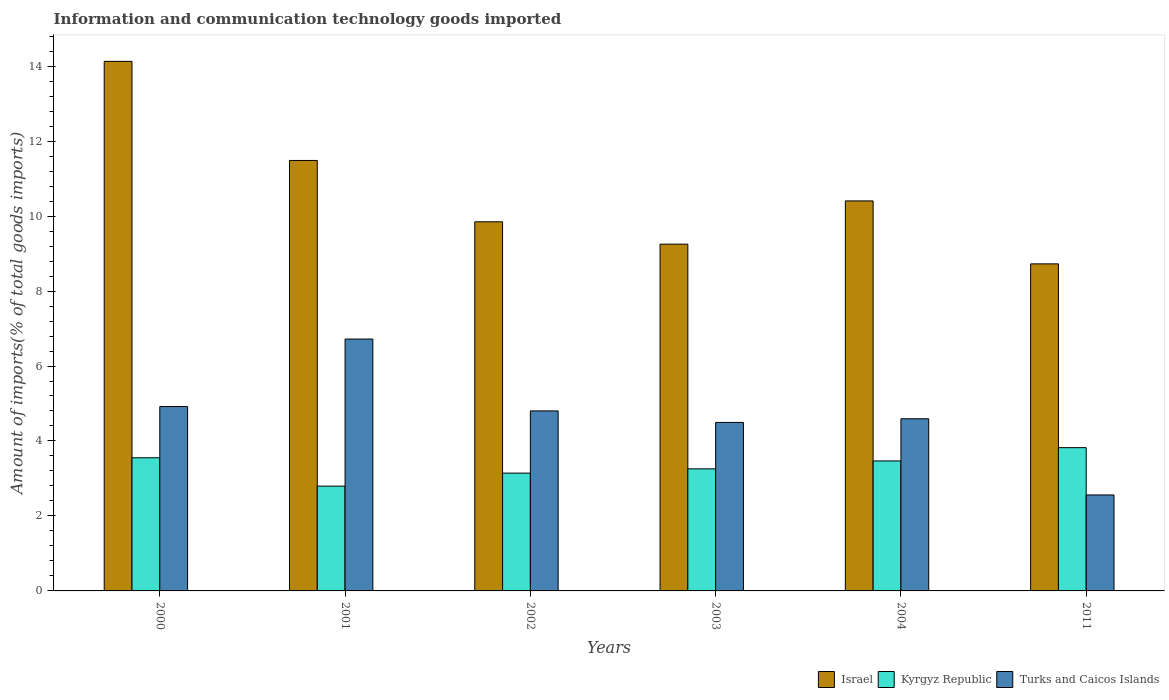Are the number of bars per tick equal to the number of legend labels?
Offer a terse response. Yes. How many bars are there on the 3rd tick from the left?
Your response must be concise. 3. How many bars are there on the 5th tick from the right?
Your answer should be very brief. 3. What is the label of the 5th group of bars from the left?
Your answer should be compact. 2004. What is the amount of goods imported in Turks and Caicos Islands in 2002?
Your response must be concise. 4.8. Across all years, what is the maximum amount of goods imported in Turks and Caicos Islands?
Make the answer very short. 6.72. Across all years, what is the minimum amount of goods imported in Turks and Caicos Islands?
Make the answer very short. 2.56. What is the total amount of goods imported in Turks and Caicos Islands in the graph?
Your answer should be compact. 28.09. What is the difference between the amount of goods imported in Kyrgyz Republic in 2002 and that in 2003?
Offer a very short reply. -0.11. What is the difference between the amount of goods imported in Israel in 2002 and the amount of goods imported in Kyrgyz Republic in 2004?
Keep it short and to the point. 6.38. What is the average amount of goods imported in Kyrgyz Republic per year?
Keep it short and to the point. 3.34. In the year 2000, what is the difference between the amount of goods imported in Turks and Caicos Islands and amount of goods imported in Kyrgyz Republic?
Provide a short and direct response. 1.37. In how many years, is the amount of goods imported in Kyrgyz Republic greater than 14 %?
Offer a terse response. 0. What is the ratio of the amount of goods imported in Turks and Caicos Islands in 2001 to that in 2004?
Your answer should be compact. 1.46. Is the difference between the amount of goods imported in Turks and Caicos Islands in 2002 and 2011 greater than the difference between the amount of goods imported in Kyrgyz Republic in 2002 and 2011?
Ensure brevity in your answer.  Yes. What is the difference between the highest and the second highest amount of goods imported in Israel?
Your response must be concise. 2.64. What is the difference between the highest and the lowest amount of goods imported in Kyrgyz Republic?
Your answer should be very brief. 1.03. Is the sum of the amount of goods imported in Kyrgyz Republic in 2000 and 2002 greater than the maximum amount of goods imported in Israel across all years?
Your answer should be compact. No. What does the 3rd bar from the left in 2000 represents?
Offer a very short reply. Turks and Caicos Islands. What does the 1st bar from the right in 2003 represents?
Keep it short and to the point. Turks and Caicos Islands. How many years are there in the graph?
Make the answer very short. 6. Does the graph contain grids?
Your answer should be very brief. No. Where does the legend appear in the graph?
Your response must be concise. Bottom right. How many legend labels are there?
Offer a very short reply. 3. How are the legend labels stacked?
Provide a short and direct response. Horizontal. What is the title of the graph?
Your answer should be very brief. Information and communication technology goods imported. What is the label or title of the X-axis?
Keep it short and to the point. Years. What is the label or title of the Y-axis?
Make the answer very short. Amount of imports(% of total goods imports). What is the Amount of imports(% of total goods imports) in Israel in 2000?
Offer a very short reply. 14.13. What is the Amount of imports(% of total goods imports) in Kyrgyz Republic in 2000?
Offer a terse response. 3.55. What is the Amount of imports(% of total goods imports) in Turks and Caicos Islands in 2000?
Ensure brevity in your answer.  4.92. What is the Amount of imports(% of total goods imports) of Israel in 2001?
Give a very brief answer. 11.48. What is the Amount of imports(% of total goods imports) in Kyrgyz Republic in 2001?
Your response must be concise. 2.8. What is the Amount of imports(% of total goods imports) in Turks and Caicos Islands in 2001?
Offer a very short reply. 6.72. What is the Amount of imports(% of total goods imports) of Israel in 2002?
Provide a succinct answer. 9.85. What is the Amount of imports(% of total goods imports) in Kyrgyz Republic in 2002?
Your answer should be compact. 3.14. What is the Amount of imports(% of total goods imports) of Turks and Caicos Islands in 2002?
Your answer should be very brief. 4.8. What is the Amount of imports(% of total goods imports) of Israel in 2003?
Offer a terse response. 9.25. What is the Amount of imports(% of total goods imports) in Kyrgyz Republic in 2003?
Your answer should be compact. 3.26. What is the Amount of imports(% of total goods imports) of Turks and Caicos Islands in 2003?
Your answer should be very brief. 4.5. What is the Amount of imports(% of total goods imports) of Israel in 2004?
Provide a short and direct response. 10.4. What is the Amount of imports(% of total goods imports) in Kyrgyz Republic in 2004?
Offer a very short reply. 3.47. What is the Amount of imports(% of total goods imports) of Turks and Caicos Islands in 2004?
Make the answer very short. 4.59. What is the Amount of imports(% of total goods imports) in Israel in 2011?
Your answer should be very brief. 8.73. What is the Amount of imports(% of total goods imports) of Kyrgyz Republic in 2011?
Provide a short and direct response. 3.82. What is the Amount of imports(% of total goods imports) of Turks and Caicos Islands in 2011?
Offer a very short reply. 2.56. Across all years, what is the maximum Amount of imports(% of total goods imports) in Israel?
Keep it short and to the point. 14.13. Across all years, what is the maximum Amount of imports(% of total goods imports) in Kyrgyz Republic?
Offer a very short reply. 3.82. Across all years, what is the maximum Amount of imports(% of total goods imports) in Turks and Caicos Islands?
Your answer should be very brief. 6.72. Across all years, what is the minimum Amount of imports(% of total goods imports) in Israel?
Your response must be concise. 8.73. Across all years, what is the minimum Amount of imports(% of total goods imports) of Kyrgyz Republic?
Offer a very short reply. 2.8. Across all years, what is the minimum Amount of imports(% of total goods imports) in Turks and Caicos Islands?
Your answer should be compact. 2.56. What is the total Amount of imports(% of total goods imports) of Israel in the graph?
Your answer should be compact. 63.84. What is the total Amount of imports(% of total goods imports) of Kyrgyz Republic in the graph?
Offer a very short reply. 20.04. What is the total Amount of imports(% of total goods imports) in Turks and Caicos Islands in the graph?
Provide a succinct answer. 28.09. What is the difference between the Amount of imports(% of total goods imports) in Israel in 2000 and that in 2001?
Offer a very short reply. 2.64. What is the difference between the Amount of imports(% of total goods imports) of Kyrgyz Republic in 2000 and that in 2001?
Give a very brief answer. 0.76. What is the difference between the Amount of imports(% of total goods imports) in Turks and Caicos Islands in 2000 and that in 2001?
Give a very brief answer. -1.8. What is the difference between the Amount of imports(% of total goods imports) of Israel in 2000 and that in 2002?
Keep it short and to the point. 4.28. What is the difference between the Amount of imports(% of total goods imports) of Kyrgyz Republic in 2000 and that in 2002?
Provide a short and direct response. 0.41. What is the difference between the Amount of imports(% of total goods imports) of Turks and Caicos Islands in 2000 and that in 2002?
Your answer should be very brief. 0.12. What is the difference between the Amount of imports(% of total goods imports) in Israel in 2000 and that in 2003?
Make the answer very short. 4.88. What is the difference between the Amount of imports(% of total goods imports) of Kyrgyz Republic in 2000 and that in 2003?
Offer a terse response. 0.3. What is the difference between the Amount of imports(% of total goods imports) of Turks and Caicos Islands in 2000 and that in 2003?
Your answer should be compact. 0.42. What is the difference between the Amount of imports(% of total goods imports) in Israel in 2000 and that in 2004?
Give a very brief answer. 3.72. What is the difference between the Amount of imports(% of total goods imports) of Kyrgyz Republic in 2000 and that in 2004?
Make the answer very short. 0.08. What is the difference between the Amount of imports(% of total goods imports) in Turks and Caicos Islands in 2000 and that in 2004?
Ensure brevity in your answer.  0.33. What is the difference between the Amount of imports(% of total goods imports) in Israel in 2000 and that in 2011?
Keep it short and to the point. 5.4. What is the difference between the Amount of imports(% of total goods imports) in Kyrgyz Republic in 2000 and that in 2011?
Offer a terse response. -0.27. What is the difference between the Amount of imports(% of total goods imports) in Turks and Caicos Islands in 2000 and that in 2011?
Your answer should be compact. 2.36. What is the difference between the Amount of imports(% of total goods imports) in Israel in 2001 and that in 2002?
Your answer should be compact. 1.64. What is the difference between the Amount of imports(% of total goods imports) of Kyrgyz Republic in 2001 and that in 2002?
Give a very brief answer. -0.35. What is the difference between the Amount of imports(% of total goods imports) of Turks and Caicos Islands in 2001 and that in 2002?
Ensure brevity in your answer.  1.92. What is the difference between the Amount of imports(% of total goods imports) of Israel in 2001 and that in 2003?
Offer a very short reply. 2.23. What is the difference between the Amount of imports(% of total goods imports) of Kyrgyz Republic in 2001 and that in 2003?
Keep it short and to the point. -0.46. What is the difference between the Amount of imports(% of total goods imports) of Turks and Caicos Islands in 2001 and that in 2003?
Ensure brevity in your answer.  2.22. What is the difference between the Amount of imports(% of total goods imports) of Israel in 2001 and that in 2004?
Your answer should be compact. 1.08. What is the difference between the Amount of imports(% of total goods imports) of Kyrgyz Republic in 2001 and that in 2004?
Make the answer very short. -0.67. What is the difference between the Amount of imports(% of total goods imports) of Turks and Caicos Islands in 2001 and that in 2004?
Provide a short and direct response. 2.13. What is the difference between the Amount of imports(% of total goods imports) in Israel in 2001 and that in 2011?
Provide a short and direct response. 2.76. What is the difference between the Amount of imports(% of total goods imports) of Kyrgyz Republic in 2001 and that in 2011?
Your answer should be very brief. -1.03. What is the difference between the Amount of imports(% of total goods imports) in Turks and Caicos Islands in 2001 and that in 2011?
Provide a succinct answer. 4.16. What is the difference between the Amount of imports(% of total goods imports) in Israel in 2002 and that in 2003?
Offer a very short reply. 0.6. What is the difference between the Amount of imports(% of total goods imports) of Kyrgyz Republic in 2002 and that in 2003?
Provide a short and direct response. -0.11. What is the difference between the Amount of imports(% of total goods imports) of Turks and Caicos Islands in 2002 and that in 2003?
Keep it short and to the point. 0.31. What is the difference between the Amount of imports(% of total goods imports) of Israel in 2002 and that in 2004?
Make the answer very short. -0.56. What is the difference between the Amount of imports(% of total goods imports) in Kyrgyz Republic in 2002 and that in 2004?
Ensure brevity in your answer.  -0.32. What is the difference between the Amount of imports(% of total goods imports) in Turks and Caicos Islands in 2002 and that in 2004?
Your answer should be very brief. 0.21. What is the difference between the Amount of imports(% of total goods imports) in Israel in 2002 and that in 2011?
Offer a terse response. 1.12. What is the difference between the Amount of imports(% of total goods imports) in Kyrgyz Republic in 2002 and that in 2011?
Keep it short and to the point. -0.68. What is the difference between the Amount of imports(% of total goods imports) of Turks and Caicos Islands in 2002 and that in 2011?
Provide a succinct answer. 2.24. What is the difference between the Amount of imports(% of total goods imports) of Israel in 2003 and that in 2004?
Provide a short and direct response. -1.15. What is the difference between the Amount of imports(% of total goods imports) of Kyrgyz Republic in 2003 and that in 2004?
Offer a terse response. -0.21. What is the difference between the Amount of imports(% of total goods imports) in Turks and Caicos Islands in 2003 and that in 2004?
Provide a succinct answer. -0.1. What is the difference between the Amount of imports(% of total goods imports) of Israel in 2003 and that in 2011?
Provide a succinct answer. 0.53. What is the difference between the Amount of imports(% of total goods imports) in Kyrgyz Republic in 2003 and that in 2011?
Keep it short and to the point. -0.57. What is the difference between the Amount of imports(% of total goods imports) in Turks and Caicos Islands in 2003 and that in 2011?
Offer a very short reply. 1.93. What is the difference between the Amount of imports(% of total goods imports) of Israel in 2004 and that in 2011?
Your answer should be compact. 1.68. What is the difference between the Amount of imports(% of total goods imports) in Kyrgyz Republic in 2004 and that in 2011?
Your answer should be very brief. -0.35. What is the difference between the Amount of imports(% of total goods imports) in Turks and Caicos Islands in 2004 and that in 2011?
Your answer should be very brief. 2.03. What is the difference between the Amount of imports(% of total goods imports) in Israel in 2000 and the Amount of imports(% of total goods imports) in Kyrgyz Republic in 2001?
Provide a short and direct response. 11.33. What is the difference between the Amount of imports(% of total goods imports) in Israel in 2000 and the Amount of imports(% of total goods imports) in Turks and Caicos Islands in 2001?
Your answer should be compact. 7.41. What is the difference between the Amount of imports(% of total goods imports) in Kyrgyz Republic in 2000 and the Amount of imports(% of total goods imports) in Turks and Caicos Islands in 2001?
Make the answer very short. -3.17. What is the difference between the Amount of imports(% of total goods imports) in Israel in 2000 and the Amount of imports(% of total goods imports) in Kyrgyz Republic in 2002?
Give a very brief answer. 10.98. What is the difference between the Amount of imports(% of total goods imports) of Israel in 2000 and the Amount of imports(% of total goods imports) of Turks and Caicos Islands in 2002?
Give a very brief answer. 9.32. What is the difference between the Amount of imports(% of total goods imports) of Kyrgyz Republic in 2000 and the Amount of imports(% of total goods imports) of Turks and Caicos Islands in 2002?
Your answer should be compact. -1.25. What is the difference between the Amount of imports(% of total goods imports) of Israel in 2000 and the Amount of imports(% of total goods imports) of Kyrgyz Republic in 2003?
Give a very brief answer. 10.87. What is the difference between the Amount of imports(% of total goods imports) of Israel in 2000 and the Amount of imports(% of total goods imports) of Turks and Caicos Islands in 2003?
Keep it short and to the point. 9.63. What is the difference between the Amount of imports(% of total goods imports) in Kyrgyz Republic in 2000 and the Amount of imports(% of total goods imports) in Turks and Caicos Islands in 2003?
Offer a very short reply. -0.94. What is the difference between the Amount of imports(% of total goods imports) in Israel in 2000 and the Amount of imports(% of total goods imports) in Kyrgyz Republic in 2004?
Give a very brief answer. 10.66. What is the difference between the Amount of imports(% of total goods imports) of Israel in 2000 and the Amount of imports(% of total goods imports) of Turks and Caicos Islands in 2004?
Ensure brevity in your answer.  9.53. What is the difference between the Amount of imports(% of total goods imports) in Kyrgyz Republic in 2000 and the Amount of imports(% of total goods imports) in Turks and Caicos Islands in 2004?
Your answer should be compact. -1.04. What is the difference between the Amount of imports(% of total goods imports) in Israel in 2000 and the Amount of imports(% of total goods imports) in Kyrgyz Republic in 2011?
Offer a terse response. 10.31. What is the difference between the Amount of imports(% of total goods imports) of Israel in 2000 and the Amount of imports(% of total goods imports) of Turks and Caicos Islands in 2011?
Offer a very short reply. 11.57. What is the difference between the Amount of imports(% of total goods imports) of Kyrgyz Republic in 2000 and the Amount of imports(% of total goods imports) of Turks and Caicos Islands in 2011?
Provide a succinct answer. 0.99. What is the difference between the Amount of imports(% of total goods imports) in Israel in 2001 and the Amount of imports(% of total goods imports) in Kyrgyz Republic in 2002?
Your response must be concise. 8.34. What is the difference between the Amount of imports(% of total goods imports) of Israel in 2001 and the Amount of imports(% of total goods imports) of Turks and Caicos Islands in 2002?
Provide a short and direct response. 6.68. What is the difference between the Amount of imports(% of total goods imports) of Kyrgyz Republic in 2001 and the Amount of imports(% of total goods imports) of Turks and Caicos Islands in 2002?
Your response must be concise. -2.01. What is the difference between the Amount of imports(% of total goods imports) of Israel in 2001 and the Amount of imports(% of total goods imports) of Kyrgyz Republic in 2003?
Provide a succinct answer. 8.23. What is the difference between the Amount of imports(% of total goods imports) of Israel in 2001 and the Amount of imports(% of total goods imports) of Turks and Caicos Islands in 2003?
Provide a succinct answer. 6.99. What is the difference between the Amount of imports(% of total goods imports) of Kyrgyz Republic in 2001 and the Amount of imports(% of total goods imports) of Turks and Caicos Islands in 2003?
Make the answer very short. -1.7. What is the difference between the Amount of imports(% of total goods imports) in Israel in 2001 and the Amount of imports(% of total goods imports) in Kyrgyz Republic in 2004?
Keep it short and to the point. 8.02. What is the difference between the Amount of imports(% of total goods imports) in Israel in 2001 and the Amount of imports(% of total goods imports) in Turks and Caicos Islands in 2004?
Keep it short and to the point. 6.89. What is the difference between the Amount of imports(% of total goods imports) of Kyrgyz Republic in 2001 and the Amount of imports(% of total goods imports) of Turks and Caicos Islands in 2004?
Give a very brief answer. -1.8. What is the difference between the Amount of imports(% of total goods imports) of Israel in 2001 and the Amount of imports(% of total goods imports) of Kyrgyz Republic in 2011?
Make the answer very short. 7.66. What is the difference between the Amount of imports(% of total goods imports) in Israel in 2001 and the Amount of imports(% of total goods imports) in Turks and Caicos Islands in 2011?
Provide a short and direct response. 8.92. What is the difference between the Amount of imports(% of total goods imports) of Kyrgyz Republic in 2001 and the Amount of imports(% of total goods imports) of Turks and Caicos Islands in 2011?
Keep it short and to the point. 0.24. What is the difference between the Amount of imports(% of total goods imports) in Israel in 2002 and the Amount of imports(% of total goods imports) in Kyrgyz Republic in 2003?
Offer a very short reply. 6.59. What is the difference between the Amount of imports(% of total goods imports) in Israel in 2002 and the Amount of imports(% of total goods imports) in Turks and Caicos Islands in 2003?
Your response must be concise. 5.35. What is the difference between the Amount of imports(% of total goods imports) of Kyrgyz Republic in 2002 and the Amount of imports(% of total goods imports) of Turks and Caicos Islands in 2003?
Provide a succinct answer. -1.35. What is the difference between the Amount of imports(% of total goods imports) in Israel in 2002 and the Amount of imports(% of total goods imports) in Kyrgyz Republic in 2004?
Your answer should be very brief. 6.38. What is the difference between the Amount of imports(% of total goods imports) in Israel in 2002 and the Amount of imports(% of total goods imports) in Turks and Caicos Islands in 2004?
Offer a terse response. 5.25. What is the difference between the Amount of imports(% of total goods imports) of Kyrgyz Republic in 2002 and the Amount of imports(% of total goods imports) of Turks and Caicos Islands in 2004?
Keep it short and to the point. -1.45. What is the difference between the Amount of imports(% of total goods imports) in Israel in 2002 and the Amount of imports(% of total goods imports) in Kyrgyz Republic in 2011?
Your response must be concise. 6.02. What is the difference between the Amount of imports(% of total goods imports) in Israel in 2002 and the Amount of imports(% of total goods imports) in Turks and Caicos Islands in 2011?
Your response must be concise. 7.29. What is the difference between the Amount of imports(% of total goods imports) in Kyrgyz Republic in 2002 and the Amount of imports(% of total goods imports) in Turks and Caicos Islands in 2011?
Your response must be concise. 0.58. What is the difference between the Amount of imports(% of total goods imports) in Israel in 2003 and the Amount of imports(% of total goods imports) in Kyrgyz Republic in 2004?
Give a very brief answer. 5.78. What is the difference between the Amount of imports(% of total goods imports) in Israel in 2003 and the Amount of imports(% of total goods imports) in Turks and Caicos Islands in 2004?
Keep it short and to the point. 4.66. What is the difference between the Amount of imports(% of total goods imports) in Kyrgyz Republic in 2003 and the Amount of imports(% of total goods imports) in Turks and Caicos Islands in 2004?
Provide a succinct answer. -1.34. What is the difference between the Amount of imports(% of total goods imports) in Israel in 2003 and the Amount of imports(% of total goods imports) in Kyrgyz Republic in 2011?
Offer a very short reply. 5.43. What is the difference between the Amount of imports(% of total goods imports) of Israel in 2003 and the Amount of imports(% of total goods imports) of Turks and Caicos Islands in 2011?
Offer a terse response. 6.69. What is the difference between the Amount of imports(% of total goods imports) of Kyrgyz Republic in 2003 and the Amount of imports(% of total goods imports) of Turks and Caicos Islands in 2011?
Make the answer very short. 0.7. What is the difference between the Amount of imports(% of total goods imports) of Israel in 2004 and the Amount of imports(% of total goods imports) of Kyrgyz Republic in 2011?
Give a very brief answer. 6.58. What is the difference between the Amount of imports(% of total goods imports) in Israel in 2004 and the Amount of imports(% of total goods imports) in Turks and Caicos Islands in 2011?
Give a very brief answer. 7.84. What is the difference between the Amount of imports(% of total goods imports) in Kyrgyz Republic in 2004 and the Amount of imports(% of total goods imports) in Turks and Caicos Islands in 2011?
Offer a very short reply. 0.91. What is the average Amount of imports(% of total goods imports) in Israel per year?
Your answer should be compact. 10.64. What is the average Amount of imports(% of total goods imports) in Kyrgyz Republic per year?
Provide a short and direct response. 3.34. What is the average Amount of imports(% of total goods imports) in Turks and Caicos Islands per year?
Provide a succinct answer. 4.68. In the year 2000, what is the difference between the Amount of imports(% of total goods imports) in Israel and Amount of imports(% of total goods imports) in Kyrgyz Republic?
Your answer should be very brief. 10.58. In the year 2000, what is the difference between the Amount of imports(% of total goods imports) in Israel and Amount of imports(% of total goods imports) in Turks and Caicos Islands?
Your answer should be very brief. 9.21. In the year 2000, what is the difference between the Amount of imports(% of total goods imports) of Kyrgyz Republic and Amount of imports(% of total goods imports) of Turks and Caicos Islands?
Provide a short and direct response. -1.37. In the year 2001, what is the difference between the Amount of imports(% of total goods imports) in Israel and Amount of imports(% of total goods imports) in Kyrgyz Republic?
Ensure brevity in your answer.  8.69. In the year 2001, what is the difference between the Amount of imports(% of total goods imports) in Israel and Amount of imports(% of total goods imports) in Turks and Caicos Islands?
Keep it short and to the point. 4.76. In the year 2001, what is the difference between the Amount of imports(% of total goods imports) in Kyrgyz Republic and Amount of imports(% of total goods imports) in Turks and Caicos Islands?
Offer a terse response. -3.92. In the year 2002, what is the difference between the Amount of imports(% of total goods imports) of Israel and Amount of imports(% of total goods imports) of Kyrgyz Republic?
Offer a terse response. 6.7. In the year 2002, what is the difference between the Amount of imports(% of total goods imports) in Israel and Amount of imports(% of total goods imports) in Turks and Caicos Islands?
Provide a succinct answer. 5.04. In the year 2002, what is the difference between the Amount of imports(% of total goods imports) of Kyrgyz Republic and Amount of imports(% of total goods imports) of Turks and Caicos Islands?
Keep it short and to the point. -1.66. In the year 2003, what is the difference between the Amount of imports(% of total goods imports) of Israel and Amount of imports(% of total goods imports) of Kyrgyz Republic?
Provide a succinct answer. 5.99. In the year 2003, what is the difference between the Amount of imports(% of total goods imports) of Israel and Amount of imports(% of total goods imports) of Turks and Caicos Islands?
Your answer should be compact. 4.76. In the year 2003, what is the difference between the Amount of imports(% of total goods imports) of Kyrgyz Republic and Amount of imports(% of total goods imports) of Turks and Caicos Islands?
Provide a short and direct response. -1.24. In the year 2004, what is the difference between the Amount of imports(% of total goods imports) of Israel and Amount of imports(% of total goods imports) of Kyrgyz Republic?
Your answer should be very brief. 6.94. In the year 2004, what is the difference between the Amount of imports(% of total goods imports) of Israel and Amount of imports(% of total goods imports) of Turks and Caicos Islands?
Offer a very short reply. 5.81. In the year 2004, what is the difference between the Amount of imports(% of total goods imports) in Kyrgyz Republic and Amount of imports(% of total goods imports) in Turks and Caicos Islands?
Offer a terse response. -1.13. In the year 2011, what is the difference between the Amount of imports(% of total goods imports) in Israel and Amount of imports(% of total goods imports) in Kyrgyz Republic?
Provide a short and direct response. 4.9. In the year 2011, what is the difference between the Amount of imports(% of total goods imports) in Israel and Amount of imports(% of total goods imports) in Turks and Caicos Islands?
Your answer should be compact. 6.16. In the year 2011, what is the difference between the Amount of imports(% of total goods imports) in Kyrgyz Republic and Amount of imports(% of total goods imports) in Turks and Caicos Islands?
Ensure brevity in your answer.  1.26. What is the ratio of the Amount of imports(% of total goods imports) in Israel in 2000 to that in 2001?
Give a very brief answer. 1.23. What is the ratio of the Amount of imports(% of total goods imports) in Kyrgyz Republic in 2000 to that in 2001?
Keep it short and to the point. 1.27. What is the ratio of the Amount of imports(% of total goods imports) in Turks and Caicos Islands in 2000 to that in 2001?
Provide a succinct answer. 0.73. What is the ratio of the Amount of imports(% of total goods imports) of Israel in 2000 to that in 2002?
Your answer should be compact. 1.43. What is the ratio of the Amount of imports(% of total goods imports) of Kyrgyz Republic in 2000 to that in 2002?
Your answer should be very brief. 1.13. What is the ratio of the Amount of imports(% of total goods imports) in Turks and Caicos Islands in 2000 to that in 2002?
Give a very brief answer. 1.02. What is the ratio of the Amount of imports(% of total goods imports) in Israel in 2000 to that in 2003?
Offer a terse response. 1.53. What is the ratio of the Amount of imports(% of total goods imports) of Kyrgyz Republic in 2000 to that in 2003?
Make the answer very short. 1.09. What is the ratio of the Amount of imports(% of total goods imports) in Turks and Caicos Islands in 2000 to that in 2003?
Offer a very short reply. 1.09. What is the ratio of the Amount of imports(% of total goods imports) of Israel in 2000 to that in 2004?
Provide a short and direct response. 1.36. What is the ratio of the Amount of imports(% of total goods imports) in Kyrgyz Republic in 2000 to that in 2004?
Offer a very short reply. 1.02. What is the ratio of the Amount of imports(% of total goods imports) of Turks and Caicos Islands in 2000 to that in 2004?
Give a very brief answer. 1.07. What is the ratio of the Amount of imports(% of total goods imports) of Israel in 2000 to that in 2011?
Offer a very short reply. 1.62. What is the ratio of the Amount of imports(% of total goods imports) of Kyrgyz Republic in 2000 to that in 2011?
Your answer should be very brief. 0.93. What is the ratio of the Amount of imports(% of total goods imports) of Turks and Caicos Islands in 2000 to that in 2011?
Give a very brief answer. 1.92. What is the ratio of the Amount of imports(% of total goods imports) in Israel in 2001 to that in 2002?
Provide a succinct answer. 1.17. What is the ratio of the Amount of imports(% of total goods imports) of Kyrgyz Republic in 2001 to that in 2002?
Give a very brief answer. 0.89. What is the ratio of the Amount of imports(% of total goods imports) of Turks and Caicos Islands in 2001 to that in 2002?
Offer a very short reply. 1.4. What is the ratio of the Amount of imports(% of total goods imports) in Israel in 2001 to that in 2003?
Make the answer very short. 1.24. What is the ratio of the Amount of imports(% of total goods imports) of Kyrgyz Republic in 2001 to that in 2003?
Your response must be concise. 0.86. What is the ratio of the Amount of imports(% of total goods imports) in Turks and Caicos Islands in 2001 to that in 2003?
Provide a short and direct response. 1.49. What is the ratio of the Amount of imports(% of total goods imports) of Israel in 2001 to that in 2004?
Your answer should be compact. 1.1. What is the ratio of the Amount of imports(% of total goods imports) of Kyrgyz Republic in 2001 to that in 2004?
Give a very brief answer. 0.81. What is the ratio of the Amount of imports(% of total goods imports) in Turks and Caicos Islands in 2001 to that in 2004?
Provide a succinct answer. 1.46. What is the ratio of the Amount of imports(% of total goods imports) in Israel in 2001 to that in 2011?
Keep it short and to the point. 1.32. What is the ratio of the Amount of imports(% of total goods imports) of Kyrgyz Republic in 2001 to that in 2011?
Offer a terse response. 0.73. What is the ratio of the Amount of imports(% of total goods imports) in Turks and Caicos Islands in 2001 to that in 2011?
Give a very brief answer. 2.62. What is the ratio of the Amount of imports(% of total goods imports) in Israel in 2002 to that in 2003?
Offer a very short reply. 1.06. What is the ratio of the Amount of imports(% of total goods imports) in Kyrgyz Republic in 2002 to that in 2003?
Offer a terse response. 0.96. What is the ratio of the Amount of imports(% of total goods imports) of Turks and Caicos Islands in 2002 to that in 2003?
Your answer should be very brief. 1.07. What is the ratio of the Amount of imports(% of total goods imports) in Israel in 2002 to that in 2004?
Make the answer very short. 0.95. What is the ratio of the Amount of imports(% of total goods imports) of Kyrgyz Republic in 2002 to that in 2004?
Offer a terse response. 0.91. What is the ratio of the Amount of imports(% of total goods imports) of Turks and Caicos Islands in 2002 to that in 2004?
Your answer should be very brief. 1.05. What is the ratio of the Amount of imports(% of total goods imports) of Israel in 2002 to that in 2011?
Your response must be concise. 1.13. What is the ratio of the Amount of imports(% of total goods imports) of Kyrgyz Republic in 2002 to that in 2011?
Your response must be concise. 0.82. What is the ratio of the Amount of imports(% of total goods imports) in Turks and Caicos Islands in 2002 to that in 2011?
Ensure brevity in your answer.  1.88. What is the ratio of the Amount of imports(% of total goods imports) in Israel in 2003 to that in 2004?
Offer a terse response. 0.89. What is the ratio of the Amount of imports(% of total goods imports) of Kyrgyz Republic in 2003 to that in 2004?
Your answer should be compact. 0.94. What is the ratio of the Amount of imports(% of total goods imports) in Turks and Caicos Islands in 2003 to that in 2004?
Your answer should be very brief. 0.98. What is the ratio of the Amount of imports(% of total goods imports) of Israel in 2003 to that in 2011?
Your answer should be very brief. 1.06. What is the ratio of the Amount of imports(% of total goods imports) of Kyrgyz Republic in 2003 to that in 2011?
Offer a terse response. 0.85. What is the ratio of the Amount of imports(% of total goods imports) in Turks and Caicos Islands in 2003 to that in 2011?
Ensure brevity in your answer.  1.76. What is the ratio of the Amount of imports(% of total goods imports) in Israel in 2004 to that in 2011?
Ensure brevity in your answer.  1.19. What is the ratio of the Amount of imports(% of total goods imports) of Kyrgyz Republic in 2004 to that in 2011?
Your response must be concise. 0.91. What is the ratio of the Amount of imports(% of total goods imports) in Turks and Caicos Islands in 2004 to that in 2011?
Your answer should be very brief. 1.79. What is the difference between the highest and the second highest Amount of imports(% of total goods imports) in Israel?
Ensure brevity in your answer.  2.64. What is the difference between the highest and the second highest Amount of imports(% of total goods imports) in Kyrgyz Republic?
Your answer should be very brief. 0.27. What is the difference between the highest and the second highest Amount of imports(% of total goods imports) in Turks and Caicos Islands?
Offer a terse response. 1.8. What is the difference between the highest and the lowest Amount of imports(% of total goods imports) in Israel?
Make the answer very short. 5.4. What is the difference between the highest and the lowest Amount of imports(% of total goods imports) in Kyrgyz Republic?
Provide a short and direct response. 1.03. What is the difference between the highest and the lowest Amount of imports(% of total goods imports) of Turks and Caicos Islands?
Offer a terse response. 4.16. 